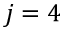<formula> <loc_0><loc_0><loc_500><loc_500>j = 4</formula> 